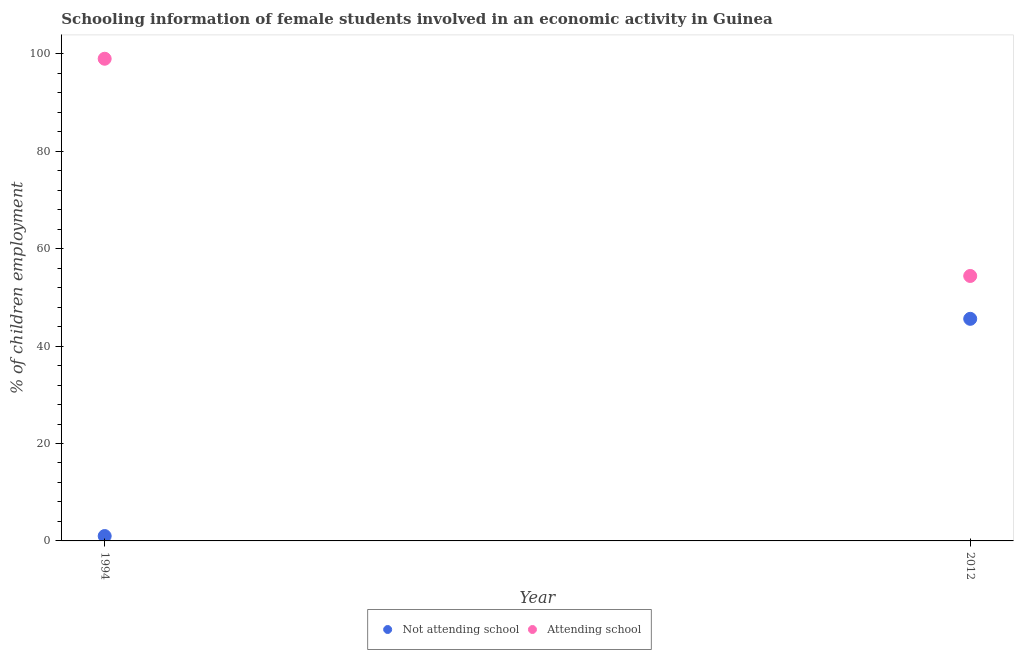Is the number of dotlines equal to the number of legend labels?
Ensure brevity in your answer.  Yes. What is the percentage of employed females who are not attending school in 1994?
Keep it short and to the point. 1. Across all years, what is the maximum percentage of employed females who are attending school?
Your answer should be compact. 99. Across all years, what is the minimum percentage of employed females who are attending school?
Provide a succinct answer. 54.4. In which year was the percentage of employed females who are attending school minimum?
Your answer should be very brief. 2012. What is the total percentage of employed females who are not attending school in the graph?
Your answer should be compact. 46.6. What is the difference between the percentage of employed females who are attending school in 1994 and that in 2012?
Your response must be concise. 44.6. What is the difference between the percentage of employed females who are not attending school in 1994 and the percentage of employed females who are attending school in 2012?
Your answer should be compact. -53.4. What is the average percentage of employed females who are attending school per year?
Provide a short and direct response. 76.7. In the year 2012, what is the difference between the percentage of employed females who are not attending school and percentage of employed females who are attending school?
Make the answer very short. -8.8. What is the ratio of the percentage of employed females who are attending school in 1994 to that in 2012?
Offer a terse response. 1.82. In how many years, is the percentage of employed females who are attending school greater than the average percentage of employed females who are attending school taken over all years?
Keep it short and to the point. 1. Is the percentage of employed females who are not attending school strictly less than the percentage of employed females who are attending school over the years?
Your answer should be compact. Yes. How many years are there in the graph?
Your answer should be compact. 2. Does the graph contain any zero values?
Make the answer very short. No. How many legend labels are there?
Offer a terse response. 2. What is the title of the graph?
Ensure brevity in your answer.  Schooling information of female students involved in an economic activity in Guinea. What is the label or title of the X-axis?
Your response must be concise. Year. What is the label or title of the Y-axis?
Offer a terse response. % of children employment. What is the % of children employment in Attending school in 1994?
Give a very brief answer. 99. What is the % of children employment of Not attending school in 2012?
Your response must be concise. 45.6. What is the % of children employment of Attending school in 2012?
Your response must be concise. 54.4. Across all years, what is the maximum % of children employment of Not attending school?
Make the answer very short. 45.6. Across all years, what is the minimum % of children employment of Attending school?
Provide a succinct answer. 54.4. What is the total % of children employment in Not attending school in the graph?
Your answer should be compact. 46.6. What is the total % of children employment of Attending school in the graph?
Offer a very short reply. 153.4. What is the difference between the % of children employment of Not attending school in 1994 and that in 2012?
Your answer should be very brief. -44.6. What is the difference between the % of children employment in Attending school in 1994 and that in 2012?
Your answer should be compact. 44.6. What is the difference between the % of children employment in Not attending school in 1994 and the % of children employment in Attending school in 2012?
Your answer should be compact. -53.4. What is the average % of children employment of Not attending school per year?
Ensure brevity in your answer.  23.3. What is the average % of children employment in Attending school per year?
Your answer should be compact. 76.7. In the year 1994, what is the difference between the % of children employment of Not attending school and % of children employment of Attending school?
Provide a succinct answer. -98. In the year 2012, what is the difference between the % of children employment in Not attending school and % of children employment in Attending school?
Ensure brevity in your answer.  -8.8. What is the ratio of the % of children employment in Not attending school in 1994 to that in 2012?
Ensure brevity in your answer.  0.02. What is the ratio of the % of children employment in Attending school in 1994 to that in 2012?
Keep it short and to the point. 1.82. What is the difference between the highest and the second highest % of children employment of Not attending school?
Your response must be concise. 44.6. What is the difference between the highest and the second highest % of children employment of Attending school?
Offer a very short reply. 44.6. What is the difference between the highest and the lowest % of children employment of Not attending school?
Make the answer very short. 44.6. What is the difference between the highest and the lowest % of children employment of Attending school?
Give a very brief answer. 44.6. 